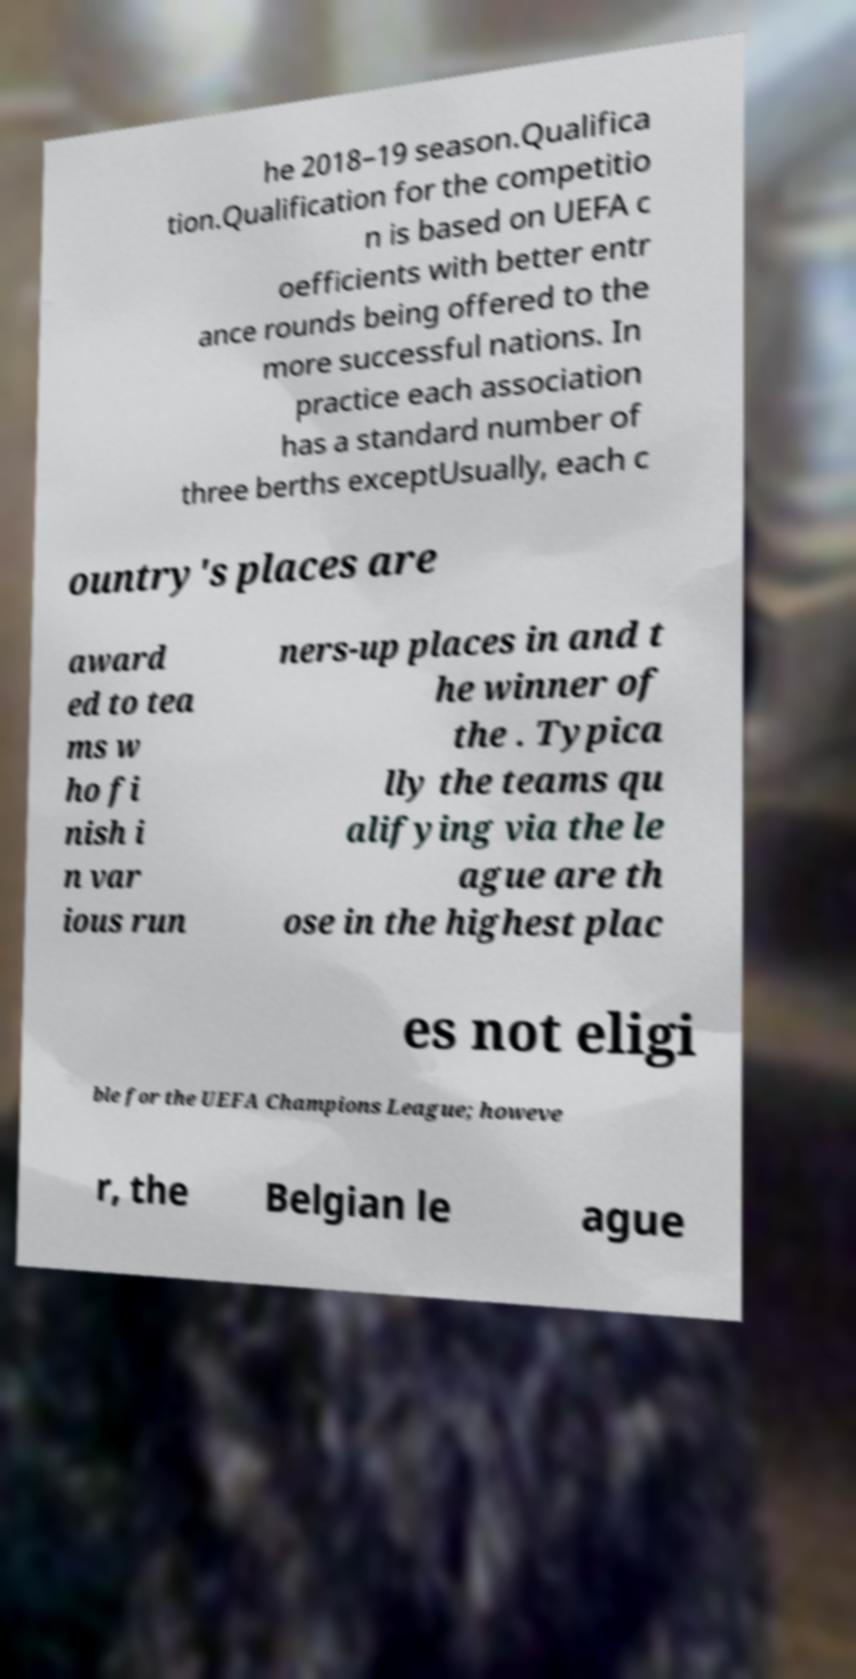There's text embedded in this image that I need extracted. Can you transcribe it verbatim? he 2018–19 season.Qualifica tion.Qualification for the competitio n is based on UEFA c oefficients with better entr ance rounds being offered to the more successful nations. In practice each association has a standard number of three berths exceptUsually, each c ountry's places are award ed to tea ms w ho fi nish i n var ious run ners-up places in and t he winner of the . Typica lly the teams qu alifying via the le ague are th ose in the highest plac es not eligi ble for the UEFA Champions League; howeve r, the Belgian le ague 